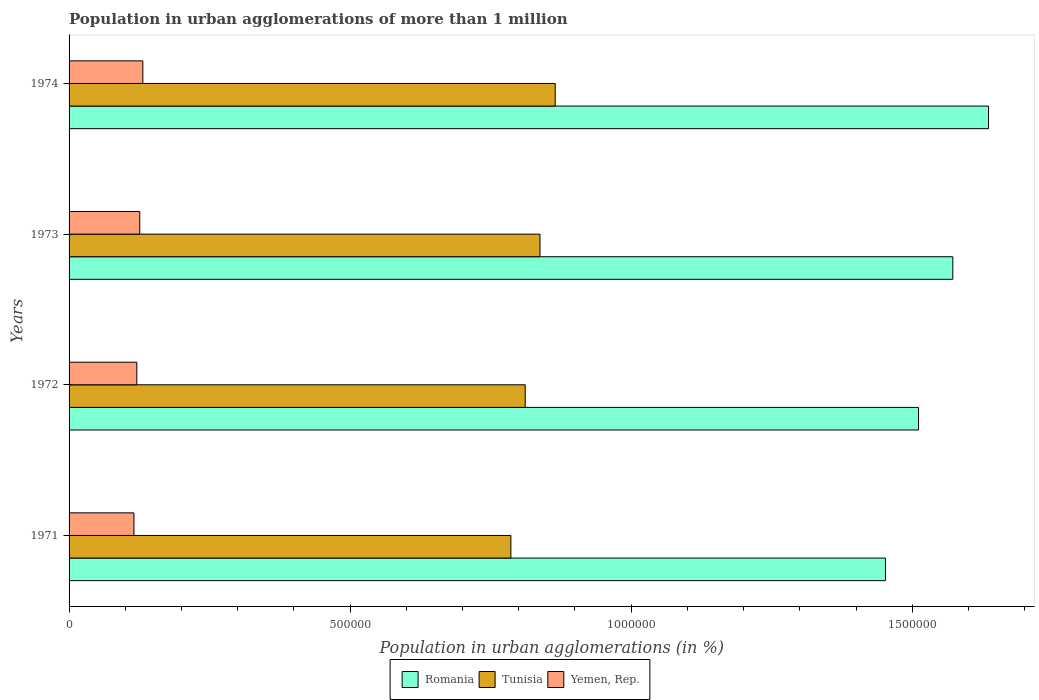Are the number of bars on each tick of the Y-axis equal?
Make the answer very short. Yes. What is the label of the 3rd group of bars from the top?
Give a very brief answer. 1972. In how many cases, is the number of bars for a given year not equal to the number of legend labels?
Give a very brief answer. 0. What is the population in urban agglomerations in Tunisia in 1972?
Keep it short and to the point. 8.11e+05. Across all years, what is the maximum population in urban agglomerations in Tunisia?
Make the answer very short. 8.65e+05. Across all years, what is the minimum population in urban agglomerations in Tunisia?
Provide a succinct answer. 7.86e+05. In which year was the population in urban agglomerations in Tunisia maximum?
Make the answer very short. 1974. In which year was the population in urban agglomerations in Tunisia minimum?
Your answer should be compact. 1971. What is the total population in urban agglomerations in Romania in the graph?
Ensure brevity in your answer.  6.17e+06. What is the difference between the population in urban agglomerations in Tunisia in 1971 and that in 1973?
Make the answer very short. -5.18e+04. What is the difference between the population in urban agglomerations in Romania in 1973 and the population in urban agglomerations in Tunisia in 1972?
Offer a very short reply. 7.61e+05. What is the average population in urban agglomerations in Yemen, Rep. per year?
Make the answer very short. 1.23e+05. In the year 1971, what is the difference between the population in urban agglomerations in Tunisia and population in urban agglomerations in Romania?
Make the answer very short. -6.66e+05. In how many years, is the population in urban agglomerations in Yemen, Rep. greater than 1200000 %?
Keep it short and to the point. 0. What is the ratio of the population in urban agglomerations in Tunisia in 1972 to that in 1974?
Ensure brevity in your answer.  0.94. Is the difference between the population in urban agglomerations in Tunisia in 1971 and 1973 greater than the difference between the population in urban agglomerations in Romania in 1971 and 1973?
Provide a short and direct response. Yes. What is the difference between the highest and the second highest population in urban agglomerations in Yemen, Rep.?
Provide a succinct answer. 5510. What is the difference between the highest and the lowest population in urban agglomerations in Romania?
Keep it short and to the point. 1.83e+05. What does the 3rd bar from the top in 1974 represents?
Your answer should be very brief. Romania. What does the 1st bar from the bottom in 1974 represents?
Ensure brevity in your answer.  Romania. Is it the case that in every year, the sum of the population in urban agglomerations in Romania and population in urban agglomerations in Tunisia is greater than the population in urban agglomerations in Yemen, Rep.?
Offer a terse response. Yes. How many bars are there?
Give a very brief answer. 12. How many years are there in the graph?
Your answer should be compact. 4. Does the graph contain grids?
Give a very brief answer. No. How many legend labels are there?
Keep it short and to the point. 3. How are the legend labels stacked?
Your answer should be very brief. Horizontal. What is the title of the graph?
Provide a succinct answer. Population in urban agglomerations of more than 1 million. What is the label or title of the X-axis?
Provide a short and direct response. Population in urban agglomerations (in %). What is the label or title of the Y-axis?
Provide a succinct answer. Years. What is the Population in urban agglomerations (in %) in Romania in 1971?
Provide a succinct answer. 1.45e+06. What is the Population in urban agglomerations (in %) of Tunisia in 1971?
Your answer should be very brief. 7.86e+05. What is the Population in urban agglomerations (in %) of Yemen, Rep. in 1971?
Ensure brevity in your answer.  1.15e+05. What is the Population in urban agglomerations (in %) of Romania in 1972?
Ensure brevity in your answer.  1.51e+06. What is the Population in urban agglomerations (in %) in Tunisia in 1972?
Provide a short and direct response. 8.11e+05. What is the Population in urban agglomerations (in %) in Yemen, Rep. in 1972?
Your answer should be compact. 1.20e+05. What is the Population in urban agglomerations (in %) of Romania in 1973?
Provide a short and direct response. 1.57e+06. What is the Population in urban agglomerations (in %) in Tunisia in 1973?
Offer a very short reply. 8.38e+05. What is the Population in urban agglomerations (in %) in Yemen, Rep. in 1973?
Make the answer very short. 1.26e+05. What is the Population in urban agglomerations (in %) in Romania in 1974?
Give a very brief answer. 1.64e+06. What is the Population in urban agglomerations (in %) of Tunisia in 1974?
Keep it short and to the point. 8.65e+05. What is the Population in urban agglomerations (in %) of Yemen, Rep. in 1974?
Provide a short and direct response. 1.31e+05. Across all years, what is the maximum Population in urban agglomerations (in %) of Romania?
Keep it short and to the point. 1.64e+06. Across all years, what is the maximum Population in urban agglomerations (in %) in Tunisia?
Make the answer very short. 8.65e+05. Across all years, what is the maximum Population in urban agglomerations (in %) of Yemen, Rep.?
Give a very brief answer. 1.31e+05. Across all years, what is the minimum Population in urban agglomerations (in %) in Romania?
Keep it short and to the point. 1.45e+06. Across all years, what is the minimum Population in urban agglomerations (in %) of Tunisia?
Your response must be concise. 7.86e+05. Across all years, what is the minimum Population in urban agglomerations (in %) in Yemen, Rep.?
Your response must be concise. 1.15e+05. What is the total Population in urban agglomerations (in %) in Romania in the graph?
Ensure brevity in your answer.  6.17e+06. What is the total Population in urban agglomerations (in %) in Tunisia in the graph?
Offer a terse response. 3.30e+06. What is the total Population in urban agglomerations (in %) in Yemen, Rep. in the graph?
Provide a short and direct response. 4.93e+05. What is the difference between the Population in urban agglomerations (in %) in Romania in 1971 and that in 1972?
Your response must be concise. -5.88e+04. What is the difference between the Population in urban agglomerations (in %) of Tunisia in 1971 and that in 1972?
Provide a short and direct response. -2.55e+04. What is the difference between the Population in urban agglomerations (in %) in Yemen, Rep. in 1971 and that in 1972?
Your response must be concise. -5064. What is the difference between the Population in urban agglomerations (in %) of Romania in 1971 and that in 1973?
Your answer should be very brief. -1.20e+05. What is the difference between the Population in urban agglomerations (in %) of Tunisia in 1971 and that in 1973?
Keep it short and to the point. -5.18e+04. What is the difference between the Population in urban agglomerations (in %) in Yemen, Rep. in 1971 and that in 1973?
Offer a very short reply. -1.03e+04. What is the difference between the Population in urban agglomerations (in %) in Romania in 1971 and that in 1974?
Offer a terse response. -1.83e+05. What is the difference between the Population in urban agglomerations (in %) of Tunisia in 1971 and that in 1974?
Keep it short and to the point. -7.89e+04. What is the difference between the Population in urban agglomerations (in %) of Yemen, Rep. in 1971 and that in 1974?
Keep it short and to the point. -1.58e+04. What is the difference between the Population in urban agglomerations (in %) in Romania in 1972 and that in 1973?
Keep it short and to the point. -6.10e+04. What is the difference between the Population in urban agglomerations (in %) of Tunisia in 1972 and that in 1973?
Make the answer very short. -2.63e+04. What is the difference between the Population in urban agglomerations (in %) in Yemen, Rep. in 1972 and that in 1973?
Provide a short and direct response. -5271. What is the difference between the Population in urban agglomerations (in %) in Romania in 1972 and that in 1974?
Provide a succinct answer. -1.24e+05. What is the difference between the Population in urban agglomerations (in %) of Tunisia in 1972 and that in 1974?
Offer a very short reply. -5.34e+04. What is the difference between the Population in urban agglomerations (in %) in Yemen, Rep. in 1972 and that in 1974?
Keep it short and to the point. -1.08e+04. What is the difference between the Population in urban agglomerations (in %) of Romania in 1973 and that in 1974?
Give a very brief answer. -6.35e+04. What is the difference between the Population in urban agglomerations (in %) in Tunisia in 1973 and that in 1974?
Your answer should be compact. -2.71e+04. What is the difference between the Population in urban agglomerations (in %) in Yemen, Rep. in 1973 and that in 1974?
Your answer should be very brief. -5510. What is the difference between the Population in urban agglomerations (in %) of Romania in 1971 and the Population in urban agglomerations (in %) of Tunisia in 1972?
Offer a terse response. 6.41e+05. What is the difference between the Population in urban agglomerations (in %) of Romania in 1971 and the Population in urban agglomerations (in %) of Yemen, Rep. in 1972?
Keep it short and to the point. 1.33e+06. What is the difference between the Population in urban agglomerations (in %) in Tunisia in 1971 and the Population in urban agglomerations (in %) in Yemen, Rep. in 1972?
Your answer should be compact. 6.66e+05. What is the difference between the Population in urban agglomerations (in %) of Romania in 1971 and the Population in urban agglomerations (in %) of Tunisia in 1973?
Offer a terse response. 6.15e+05. What is the difference between the Population in urban agglomerations (in %) of Romania in 1971 and the Population in urban agglomerations (in %) of Yemen, Rep. in 1973?
Offer a terse response. 1.33e+06. What is the difference between the Population in urban agglomerations (in %) of Tunisia in 1971 and the Population in urban agglomerations (in %) of Yemen, Rep. in 1973?
Your response must be concise. 6.60e+05. What is the difference between the Population in urban agglomerations (in %) of Romania in 1971 and the Population in urban agglomerations (in %) of Tunisia in 1974?
Offer a very short reply. 5.88e+05. What is the difference between the Population in urban agglomerations (in %) in Romania in 1971 and the Population in urban agglomerations (in %) in Yemen, Rep. in 1974?
Make the answer very short. 1.32e+06. What is the difference between the Population in urban agglomerations (in %) of Tunisia in 1971 and the Population in urban agglomerations (in %) of Yemen, Rep. in 1974?
Make the answer very short. 6.55e+05. What is the difference between the Population in urban agglomerations (in %) of Romania in 1972 and the Population in urban agglomerations (in %) of Tunisia in 1973?
Offer a terse response. 6.74e+05. What is the difference between the Population in urban agglomerations (in %) in Romania in 1972 and the Population in urban agglomerations (in %) in Yemen, Rep. in 1973?
Ensure brevity in your answer.  1.39e+06. What is the difference between the Population in urban agglomerations (in %) of Tunisia in 1972 and the Population in urban agglomerations (in %) of Yemen, Rep. in 1973?
Give a very brief answer. 6.86e+05. What is the difference between the Population in urban agglomerations (in %) of Romania in 1972 and the Population in urban agglomerations (in %) of Tunisia in 1974?
Provide a succinct answer. 6.46e+05. What is the difference between the Population in urban agglomerations (in %) of Romania in 1972 and the Population in urban agglomerations (in %) of Yemen, Rep. in 1974?
Ensure brevity in your answer.  1.38e+06. What is the difference between the Population in urban agglomerations (in %) of Tunisia in 1972 and the Population in urban agglomerations (in %) of Yemen, Rep. in 1974?
Your answer should be compact. 6.80e+05. What is the difference between the Population in urban agglomerations (in %) in Romania in 1973 and the Population in urban agglomerations (in %) in Tunisia in 1974?
Ensure brevity in your answer.  7.07e+05. What is the difference between the Population in urban agglomerations (in %) of Romania in 1973 and the Population in urban agglomerations (in %) of Yemen, Rep. in 1974?
Provide a short and direct response. 1.44e+06. What is the difference between the Population in urban agglomerations (in %) in Tunisia in 1973 and the Population in urban agglomerations (in %) in Yemen, Rep. in 1974?
Provide a short and direct response. 7.06e+05. What is the average Population in urban agglomerations (in %) of Romania per year?
Give a very brief answer. 1.54e+06. What is the average Population in urban agglomerations (in %) of Tunisia per year?
Make the answer very short. 8.25e+05. What is the average Population in urban agglomerations (in %) of Yemen, Rep. per year?
Ensure brevity in your answer.  1.23e+05. In the year 1971, what is the difference between the Population in urban agglomerations (in %) of Romania and Population in urban agglomerations (in %) of Tunisia?
Your response must be concise. 6.66e+05. In the year 1971, what is the difference between the Population in urban agglomerations (in %) of Romania and Population in urban agglomerations (in %) of Yemen, Rep.?
Your answer should be very brief. 1.34e+06. In the year 1971, what is the difference between the Population in urban agglomerations (in %) in Tunisia and Population in urban agglomerations (in %) in Yemen, Rep.?
Give a very brief answer. 6.71e+05. In the year 1972, what is the difference between the Population in urban agglomerations (in %) in Romania and Population in urban agglomerations (in %) in Tunisia?
Give a very brief answer. 7.00e+05. In the year 1972, what is the difference between the Population in urban agglomerations (in %) of Romania and Population in urban agglomerations (in %) of Yemen, Rep.?
Your answer should be compact. 1.39e+06. In the year 1972, what is the difference between the Population in urban agglomerations (in %) of Tunisia and Population in urban agglomerations (in %) of Yemen, Rep.?
Give a very brief answer. 6.91e+05. In the year 1973, what is the difference between the Population in urban agglomerations (in %) of Romania and Population in urban agglomerations (in %) of Tunisia?
Your answer should be very brief. 7.34e+05. In the year 1973, what is the difference between the Population in urban agglomerations (in %) in Romania and Population in urban agglomerations (in %) in Yemen, Rep.?
Your answer should be very brief. 1.45e+06. In the year 1973, what is the difference between the Population in urban agglomerations (in %) in Tunisia and Population in urban agglomerations (in %) in Yemen, Rep.?
Your answer should be very brief. 7.12e+05. In the year 1974, what is the difference between the Population in urban agglomerations (in %) of Romania and Population in urban agglomerations (in %) of Tunisia?
Your answer should be compact. 7.71e+05. In the year 1974, what is the difference between the Population in urban agglomerations (in %) in Romania and Population in urban agglomerations (in %) in Yemen, Rep.?
Offer a terse response. 1.50e+06. In the year 1974, what is the difference between the Population in urban agglomerations (in %) in Tunisia and Population in urban agglomerations (in %) in Yemen, Rep.?
Your answer should be compact. 7.34e+05. What is the ratio of the Population in urban agglomerations (in %) in Romania in 1971 to that in 1972?
Your answer should be compact. 0.96. What is the ratio of the Population in urban agglomerations (in %) in Tunisia in 1971 to that in 1972?
Make the answer very short. 0.97. What is the ratio of the Population in urban agglomerations (in %) in Yemen, Rep. in 1971 to that in 1972?
Your response must be concise. 0.96. What is the ratio of the Population in urban agglomerations (in %) of Romania in 1971 to that in 1973?
Your answer should be compact. 0.92. What is the ratio of the Population in urban agglomerations (in %) of Tunisia in 1971 to that in 1973?
Your response must be concise. 0.94. What is the ratio of the Population in urban agglomerations (in %) of Yemen, Rep. in 1971 to that in 1973?
Your response must be concise. 0.92. What is the ratio of the Population in urban agglomerations (in %) in Romania in 1971 to that in 1974?
Your response must be concise. 0.89. What is the ratio of the Population in urban agglomerations (in %) in Tunisia in 1971 to that in 1974?
Provide a succinct answer. 0.91. What is the ratio of the Population in urban agglomerations (in %) of Yemen, Rep. in 1971 to that in 1974?
Give a very brief answer. 0.88. What is the ratio of the Population in urban agglomerations (in %) of Romania in 1972 to that in 1973?
Make the answer very short. 0.96. What is the ratio of the Population in urban agglomerations (in %) in Tunisia in 1972 to that in 1973?
Ensure brevity in your answer.  0.97. What is the ratio of the Population in urban agglomerations (in %) of Yemen, Rep. in 1972 to that in 1973?
Your answer should be compact. 0.96. What is the ratio of the Population in urban agglomerations (in %) of Romania in 1972 to that in 1974?
Your answer should be very brief. 0.92. What is the ratio of the Population in urban agglomerations (in %) of Tunisia in 1972 to that in 1974?
Your answer should be compact. 0.94. What is the ratio of the Population in urban agglomerations (in %) of Yemen, Rep. in 1972 to that in 1974?
Your answer should be very brief. 0.92. What is the ratio of the Population in urban agglomerations (in %) in Romania in 1973 to that in 1974?
Provide a short and direct response. 0.96. What is the ratio of the Population in urban agglomerations (in %) of Tunisia in 1973 to that in 1974?
Your answer should be compact. 0.97. What is the ratio of the Population in urban agglomerations (in %) of Yemen, Rep. in 1973 to that in 1974?
Keep it short and to the point. 0.96. What is the difference between the highest and the second highest Population in urban agglomerations (in %) in Romania?
Make the answer very short. 6.35e+04. What is the difference between the highest and the second highest Population in urban agglomerations (in %) of Tunisia?
Give a very brief answer. 2.71e+04. What is the difference between the highest and the second highest Population in urban agglomerations (in %) of Yemen, Rep.?
Your answer should be very brief. 5510. What is the difference between the highest and the lowest Population in urban agglomerations (in %) of Romania?
Your answer should be very brief. 1.83e+05. What is the difference between the highest and the lowest Population in urban agglomerations (in %) in Tunisia?
Ensure brevity in your answer.  7.89e+04. What is the difference between the highest and the lowest Population in urban agglomerations (in %) in Yemen, Rep.?
Provide a succinct answer. 1.58e+04. 